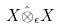<formula> <loc_0><loc_0><loc_500><loc_500>X \hat { \otimes } _ { \epsilon } X</formula> 